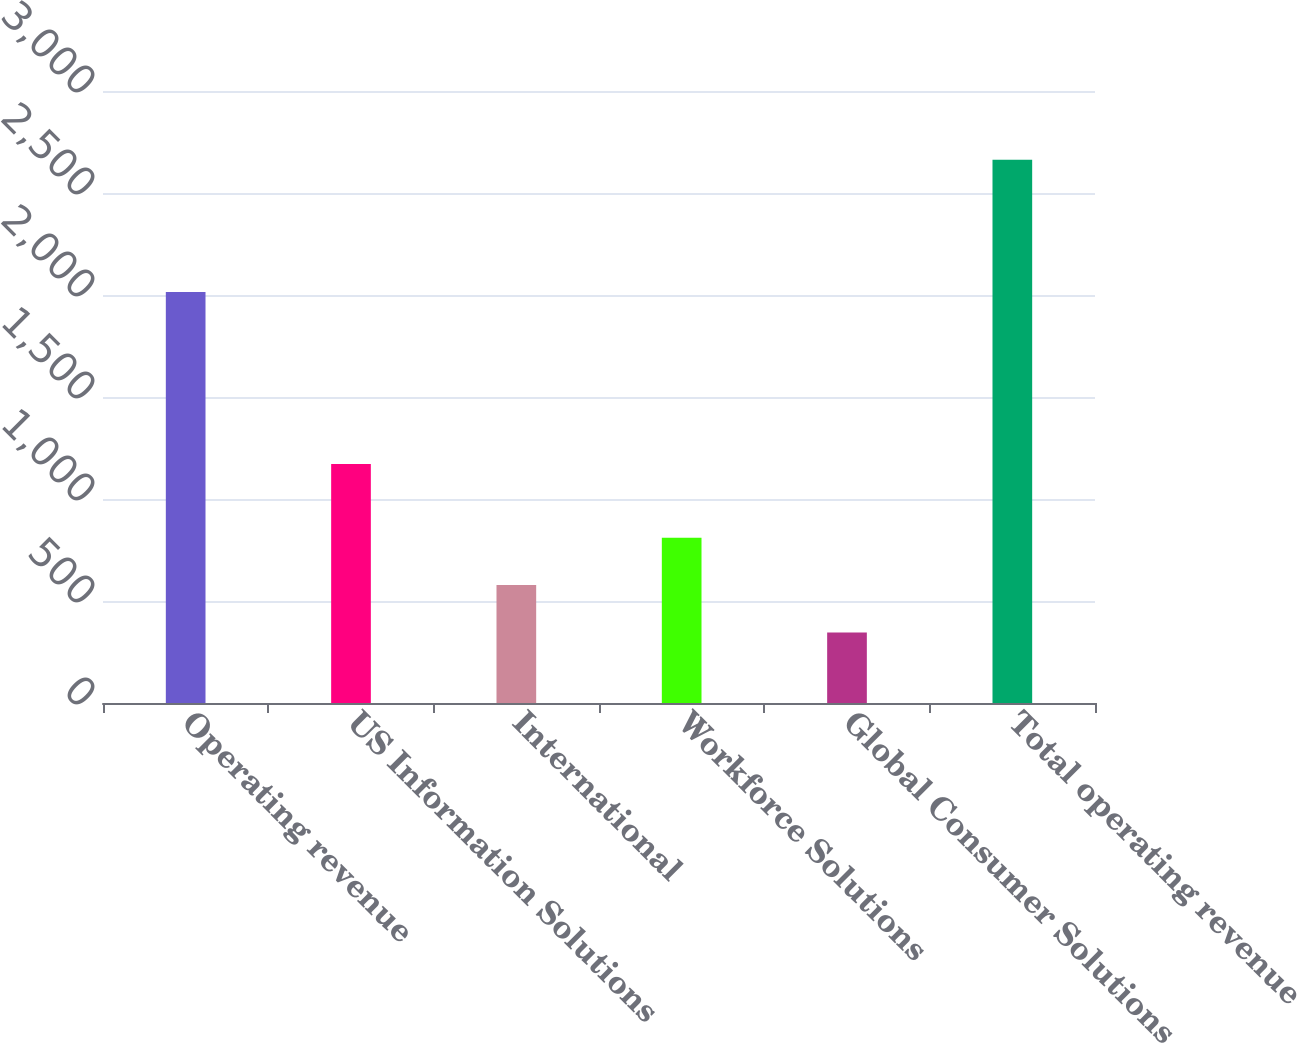Convert chart to OTSL. <chart><loc_0><loc_0><loc_500><loc_500><bar_chart><fcel>Operating revenue<fcel>US Information Solutions<fcel>International<fcel>Workforce Solutions<fcel>Global Consumer Solutions<fcel>Total operating revenue<nl><fcel>2015<fcel>1171.3<fcel>577.85<fcel>809.6<fcel>346.1<fcel>2663.6<nl></chart> 